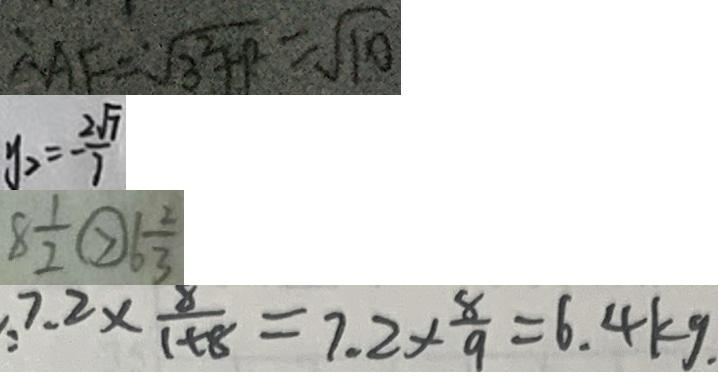Convert formula to latex. <formula><loc_0><loc_0><loc_500><loc_500>A F = \sqrt { 3 ^ { 2 } + 1 ^ { 2 } } = \sqrt { 1 0 } 
 y _ { 2 } = - \frac { 2 \sqrt { 7 } } { 7 } 
 8 \frac { 1 } { 2 } \textcircled { > } 6 \frac { 2 } { 3 } 
 7 . 2 \times \frac { 8 } { 1 + 8 } = 7 . 2 \times \frac { 8 } { 9 } = 6 . 4 k g .</formula> 